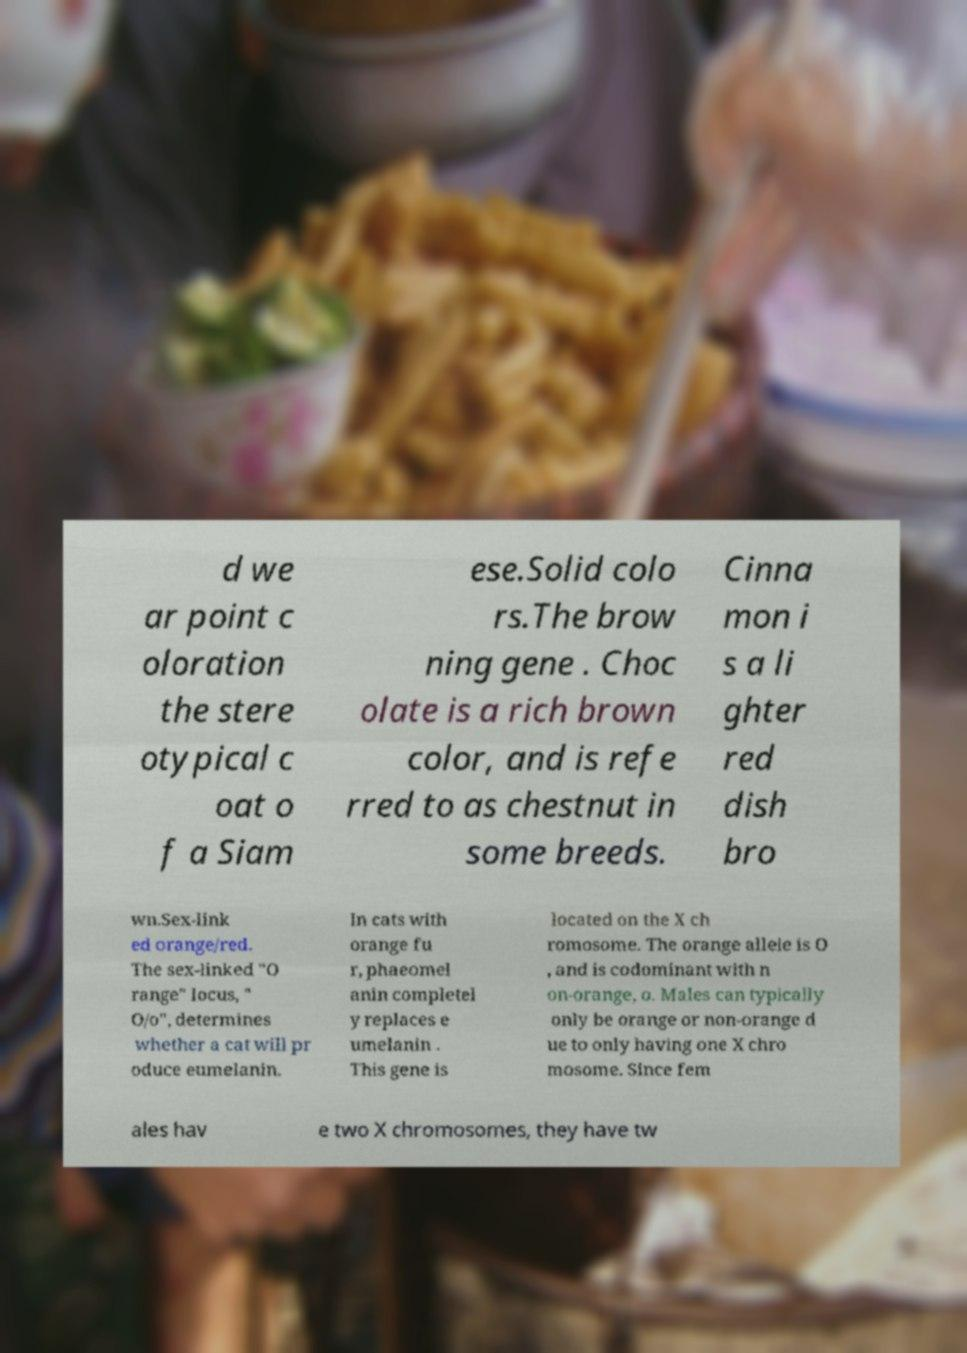What messages or text are displayed in this image? I need them in a readable, typed format. d we ar point c oloration the stere otypical c oat o f a Siam ese.Solid colo rs.The brow ning gene . Choc olate is a rich brown color, and is refe rred to as chestnut in some breeds. Cinna mon i s a li ghter red dish bro wn.Sex-link ed orange/red. The sex-linked "O range" locus, " O/o", determines whether a cat will pr oduce eumelanin. In cats with orange fu r, phaeomel anin completel y replaces e umelanin . This gene is located on the X ch romosome. The orange allele is O , and is codominant with n on-orange, o. Males can typically only be orange or non-orange d ue to only having one X chro mosome. Since fem ales hav e two X chromosomes, they have tw 